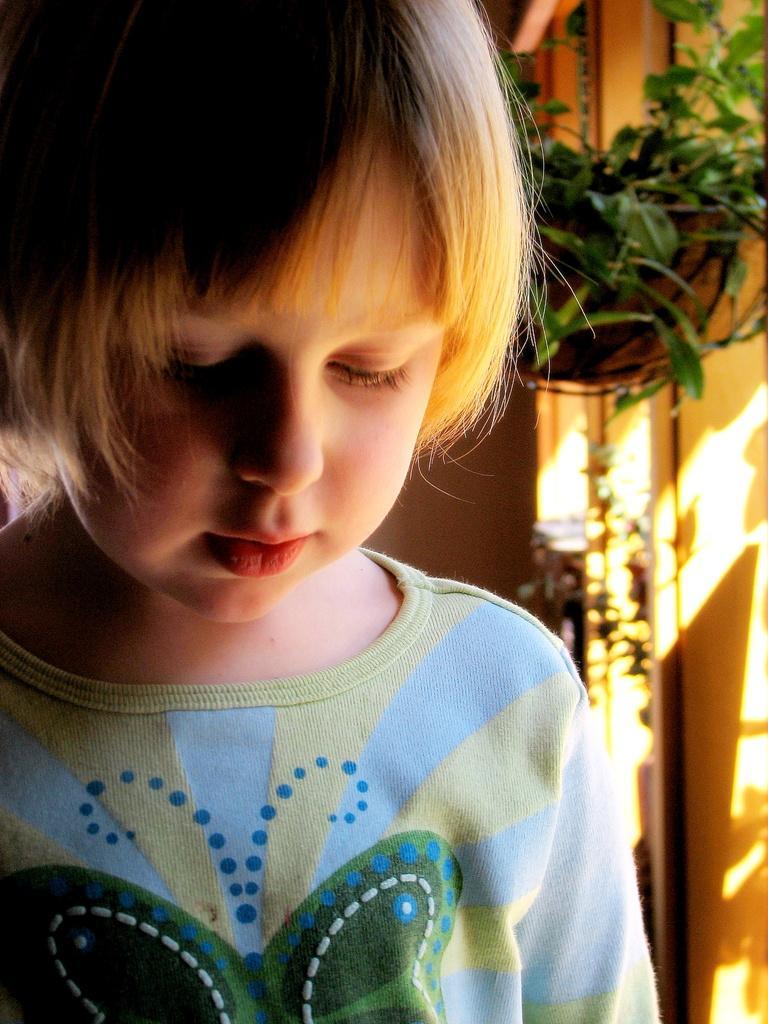In one or two sentences, can you explain what this image depicts? This is a zoomed in picture. In the foreground there is a kid wearing a t-shirt. In the background we can see a houseplant and a wall. 